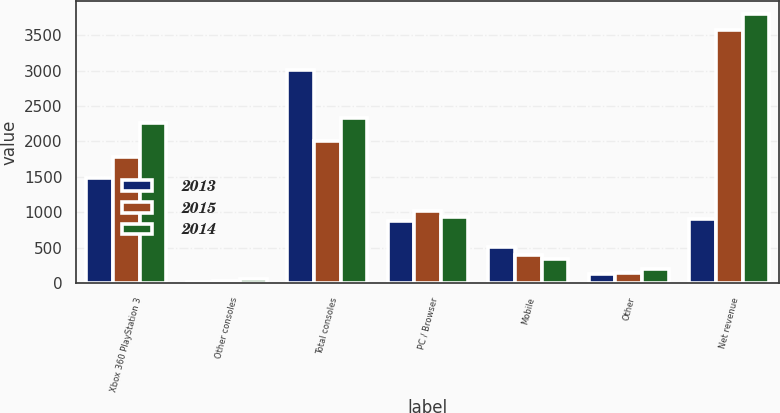Convert chart. <chart><loc_0><loc_0><loc_500><loc_500><stacked_bar_chart><ecel><fcel>Xbox 360 PlayStation 3<fcel>Other consoles<fcel>Total consoles<fcel>PC / Browser<fcel>Mobile<fcel>Other<fcel>Net revenue<nl><fcel>2013<fcel>1485<fcel>21<fcel>3011<fcel>878<fcel>504<fcel>122<fcel>903<nl><fcel>2015<fcel>1779<fcel>30<fcel>2005<fcel>1020<fcel>400<fcel>150<fcel>3575<nl><fcel>2014<fcel>2262<fcel>63<fcel>2325<fcel>928<fcel>339<fcel>205<fcel>3797<nl></chart> 